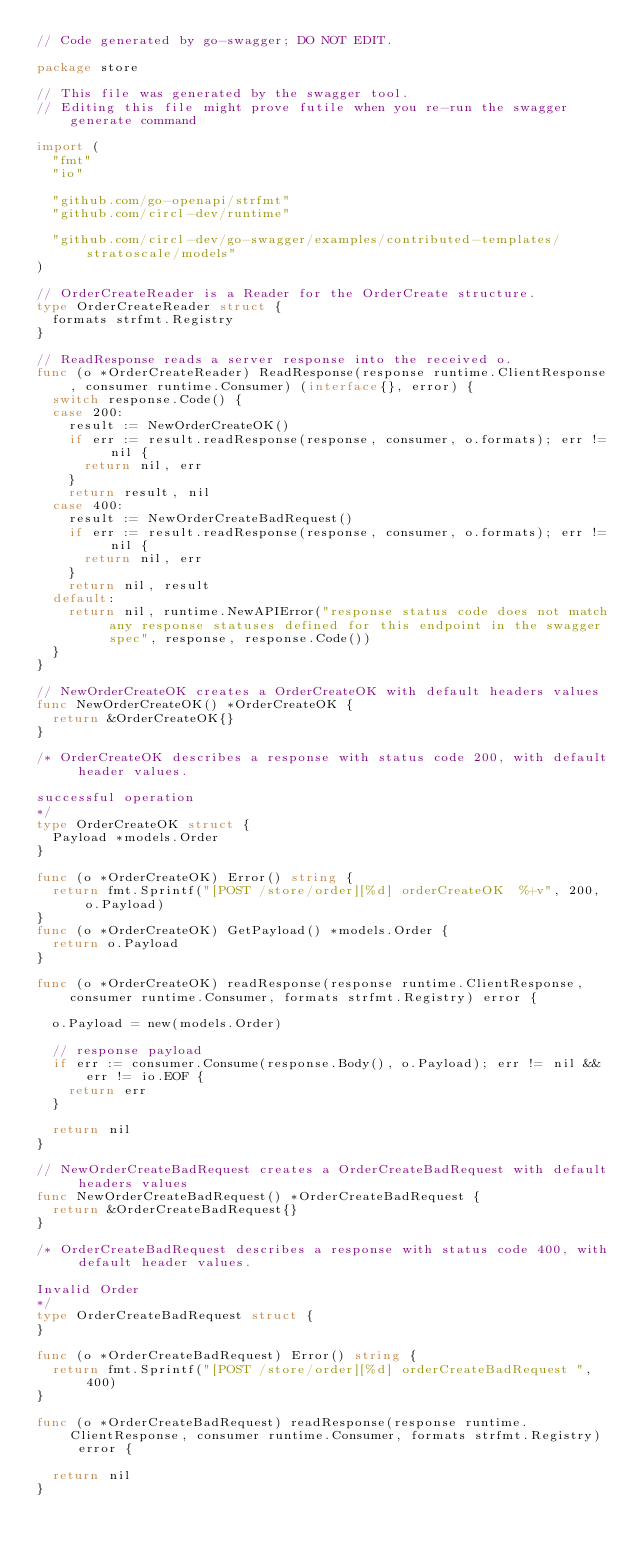Convert code to text. <code><loc_0><loc_0><loc_500><loc_500><_Go_>// Code generated by go-swagger; DO NOT EDIT.

package store

// This file was generated by the swagger tool.
// Editing this file might prove futile when you re-run the swagger generate command

import (
	"fmt"
	"io"

	"github.com/go-openapi/strfmt"
	"github.com/circl-dev/runtime"

	"github.com/circl-dev/go-swagger/examples/contributed-templates/stratoscale/models"
)

// OrderCreateReader is a Reader for the OrderCreate structure.
type OrderCreateReader struct {
	formats strfmt.Registry
}

// ReadResponse reads a server response into the received o.
func (o *OrderCreateReader) ReadResponse(response runtime.ClientResponse, consumer runtime.Consumer) (interface{}, error) {
	switch response.Code() {
	case 200:
		result := NewOrderCreateOK()
		if err := result.readResponse(response, consumer, o.formats); err != nil {
			return nil, err
		}
		return result, nil
	case 400:
		result := NewOrderCreateBadRequest()
		if err := result.readResponse(response, consumer, o.formats); err != nil {
			return nil, err
		}
		return nil, result
	default:
		return nil, runtime.NewAPIError("response status code does not match any response statuses defined for this endpoint in the swagger spec", response, response.Code())
	}
}

// NewOrderCreateOK creates a OrderCreateOK with default headers values
func NewOrderCreateOK() *OrderCreateOK {
	return &OrderCreateOK{}
}

/* OrderCreateOK describes a response with status code 200, with default header values.

successful operation
*/
type OrderCreateOK struct {
	Payload *models.Order
}

func (o *OrderCreateOK) Error() string {
	return fmt.Sprintf("[POST /store/order][%d] orderCreateOK  %+v", 200, o.Payload)
}
func (o *OrderCreateOK) GetPayload() *models.Order {
	return o.Payload
}

func (o *OrderCreateOK) readResponse(response runtime.ClientResponse, consumer runtime.Consumer, formats strfmt.Registry) error {

	o.Payload = new(models.Order)

	// response payload
	if err := consumer.Consume(response.Body(), o.Payload); err != nil && err != io.EOF {
		return err
	}

	return nil
}

// NewOrderCreateBadRequest creates a OrderCreateBadRequest with default headers values
func NewOrderCreateBadRequest() *OrderCreateBadRequest {
	return &OrderCreateBadRequest{}
}

/* OrderCreateBadRequest describes a response with status code 400, with default header values.

Invalid Order
*/
type OrderCreateBadRequest struct {
}

func (o *OrderCreateBadRequest) Error() string {
	return fmt.Sprintf("[POST /store/order][%d] orderCreateBadRequest ", 400)
}

func (o *OrderCreateBadRequest) readResponse(response runtime.ClientResponse, consumer runtime.Consumer, formats strfmt.Registry) error {

	return nil
}
</code> 